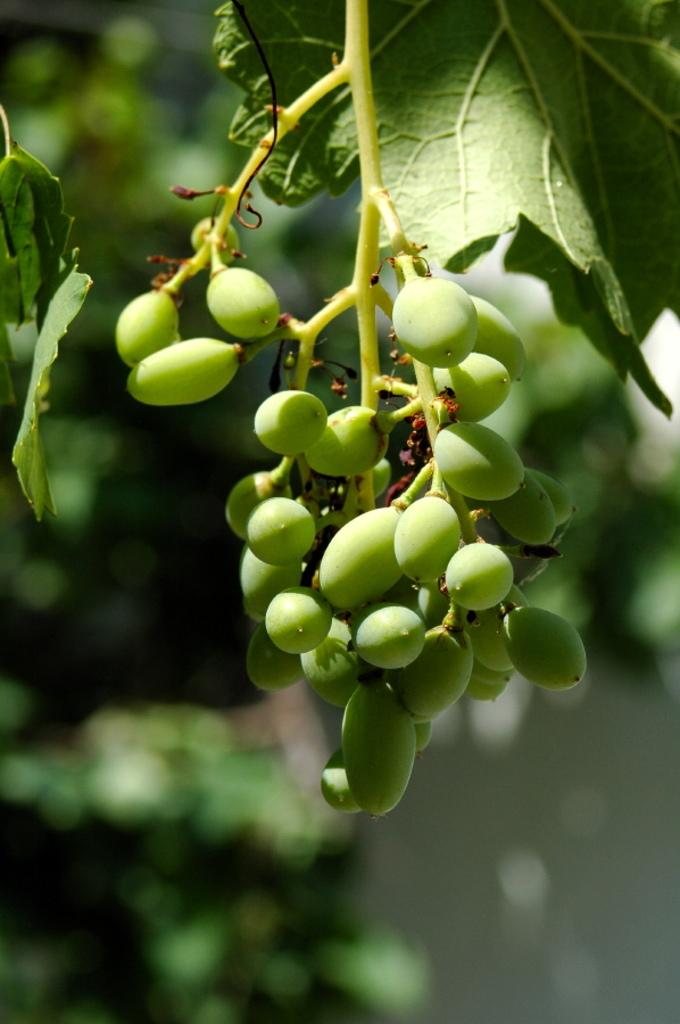What type of objects are present in the image? There are seeds and plants in the image. What is the color of the seeds and plants in the image? The seeds and plants are in green color. How does the window in the image affect the growth of the plants? There is no window present in the image; it only features seeds and plants. 